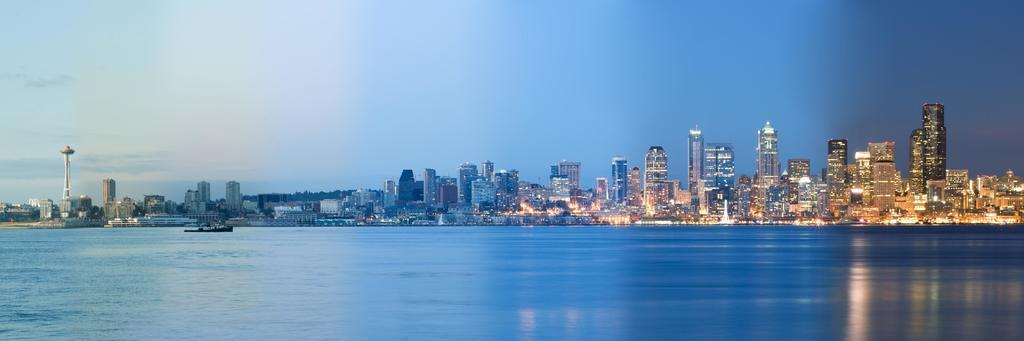What is the main subject of the image? The main subject of the image is a boat. What is the boat doing in the image? The boat is sailing on the surface of the water. What can be seen in the background of the image? There are buildings and trees in the background of the image. Where is the tower located in the image? The tower is on the left side of the image. What is visible at the top of the image? The sky is visible at the top of the image. What type of chin can be seen on the boat in the image? There is no chin present on the boat in the image, as boats do not have chins. What is the frame of the boat made of in the image? The facts provided do not mention the material or frame of the boat, so it cannot be determined from the image. 